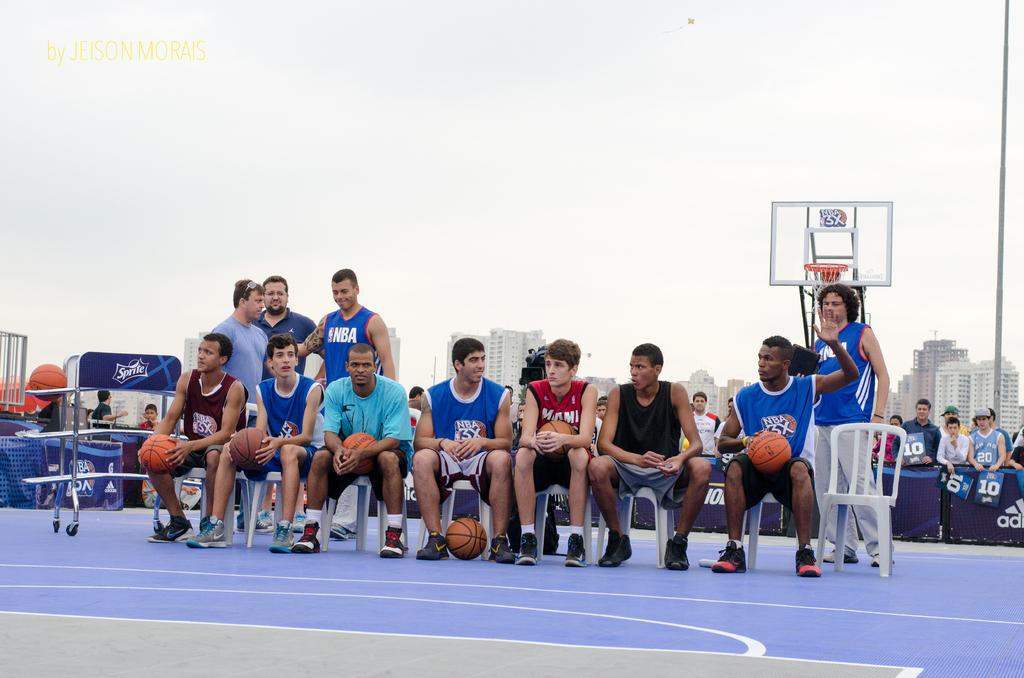Provide a one-sentence caption for the provided image. A group of baskeball players sit in chairs, one of whom is wearing a Miami jersey. 